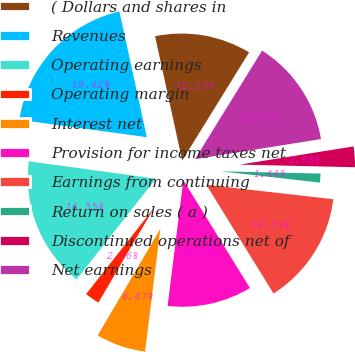Convert chart to OTSL. <chart><loc_0><loc_0><loc_500><loc_500><pie_chart><fcel>( Dollars and shares in<fcel>Revenues<fcel>Operating earnings<fcel>Operating margin<fcel>Interest net<fcel>Provision for income taxes net<fcel>Earnings from continuing<fcel>Return on sales ( a )<fcel>Discontinued operations net of<fcel>Net earnings<nl><fcel>12.23%<fcel>19.42%<fcel>16.55%<fcel>2.16%<fcel>6.47%<fcel>10.79%<fcel>14.39%<fcel>1.44%<fcel>2.88%<fcel>13.67%<nl></chart> 